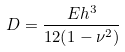<formula> <loc_0><loc_0><loc_500><loc_500>D = \frac { E h ^ { 3 } } { 1 2 ( 1 - \nu ^ { 2 } ) }</formula> 